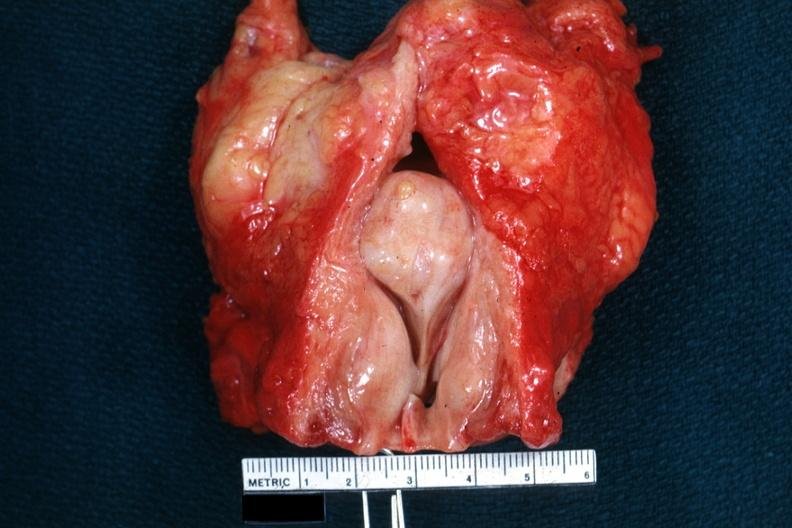what is present?
Answer the question using a single word or phrase. Prostate 